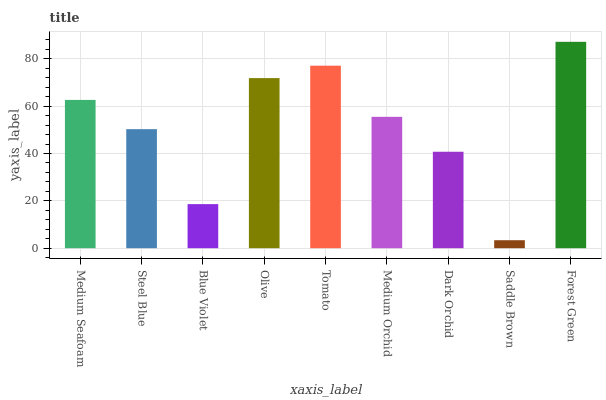Is Saddle Brown the minimum?
Answer yes or no. Yes. Is Forest Green the maximum?
Answer yes or no. Yes. Is Steel Blue the minimum?
Answer yes or no. No. Is Steel Blue the maximum?
Answer yes or no. No. Is Medium Seafoam greater than Steel Blue?
Answer yes or no. Yes. Is Steel Blue less than Medium Seafoam?
Answer yes or no. Yes. Is Steel Blue greater than Medium Seafoam?
Answer yes or no. No. Is Medium Seafoam less than Steel Blue?
Answer yes or no. No. Is Medium Orchid the high median?
Answer yes or no. Yes. Is Medium Orchid the low median?
Answer yes or no. Yes. Is Blue Violet the high median?
Answer yes or no. No. Is Dark Orchid the low median?
Answer yes or no. No. 